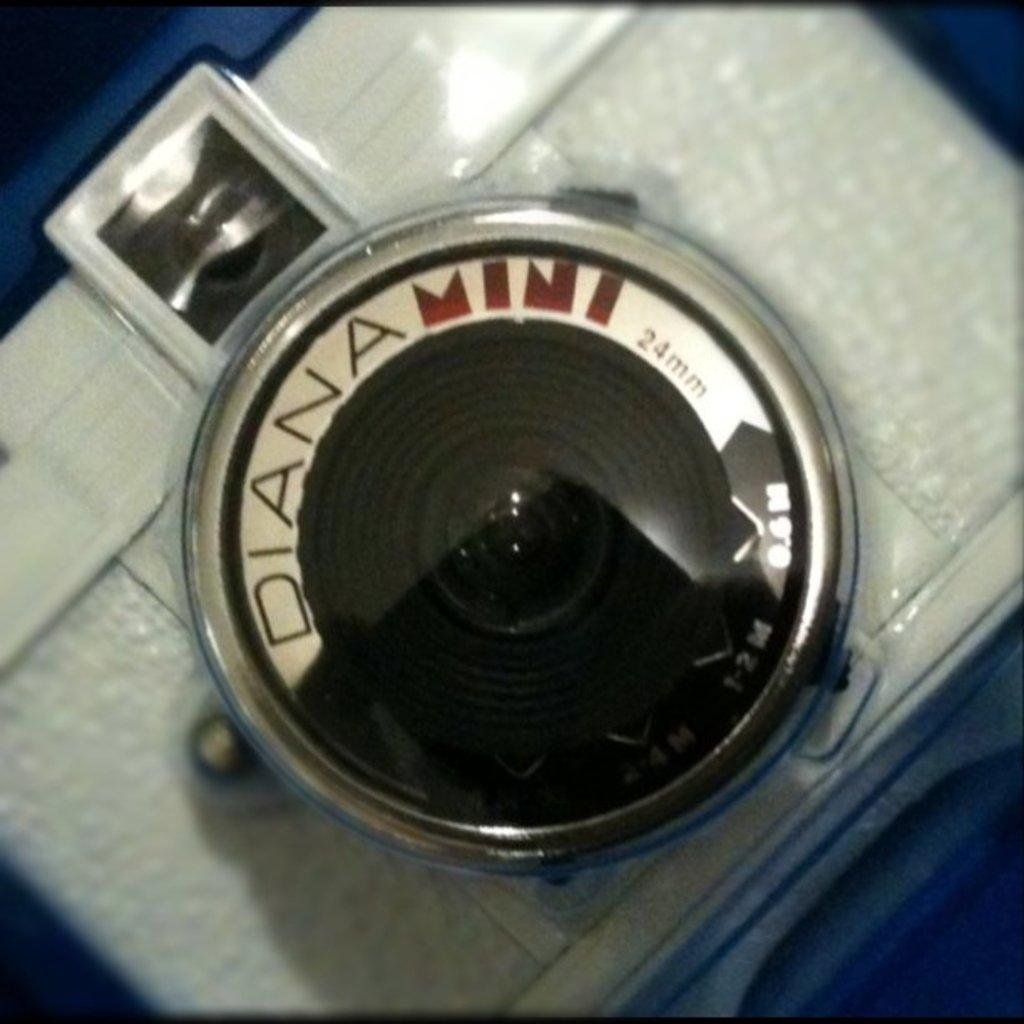What object in the image looks like a camera? There is an object in the image that resembles a camera. Can you tell me how many men are holding a bear in the bushes in the image? There is no man, bear, or bushes present in the image; it only features an object that resembles a camera. 